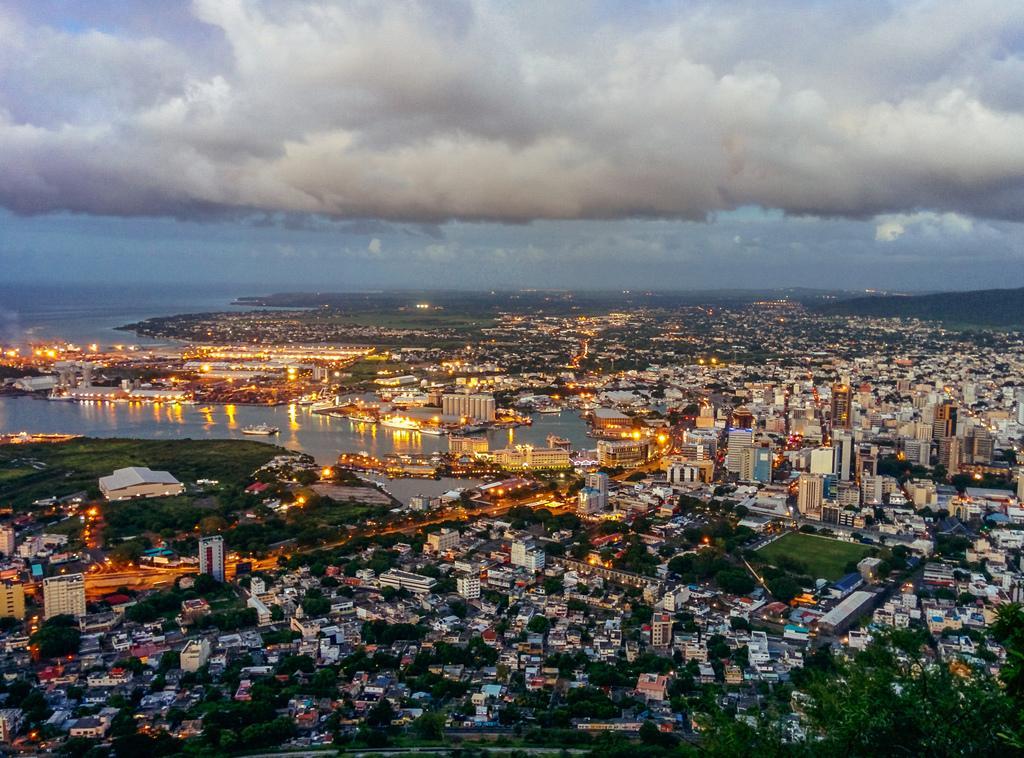Can you describe this image briefly? In this image we can see aerial view. In this image we can see buildings, trees, road, lights, ground, grass, hills, water, ships, sky and clouds. 